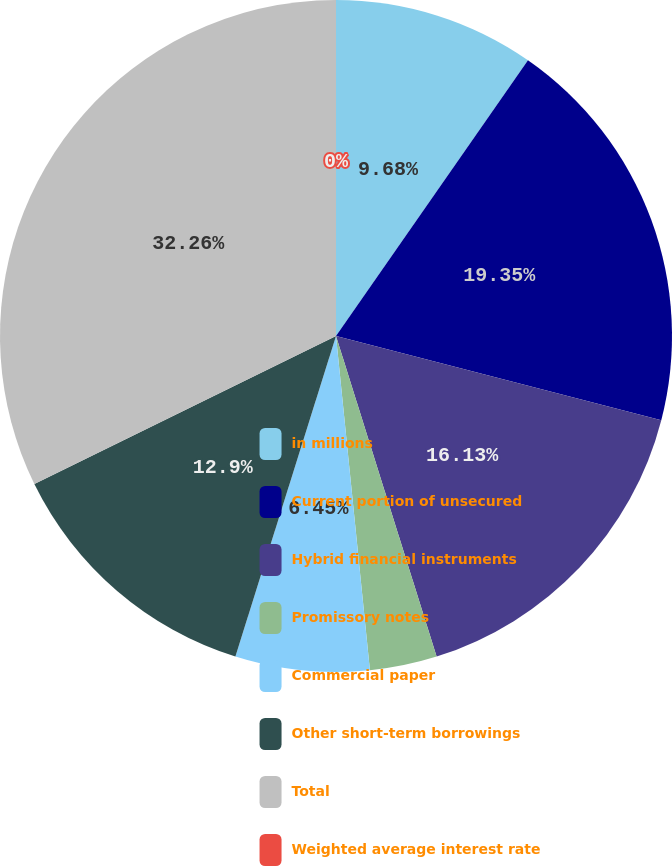Convert chart to OTSL. <chart><loc_0><loc_0><loc_500><loc_500><pie_chart><fcel>in millions<fcel>Current portion of unsecured<fcel>Hybrid financial instruments<fcel>Promissory notes<fcel>Commercial paper<fcel>Other short-term borrowings<fcel>Total<fcel>Weighted average interest rate<nl><fcel>9.68%<fcel>19.35%<fcel>16.13%<fcel>3.23%<fcel>6.45%<fcel>12.9%<fcel>32.26%<fcel>0.0%<nl></chart> 